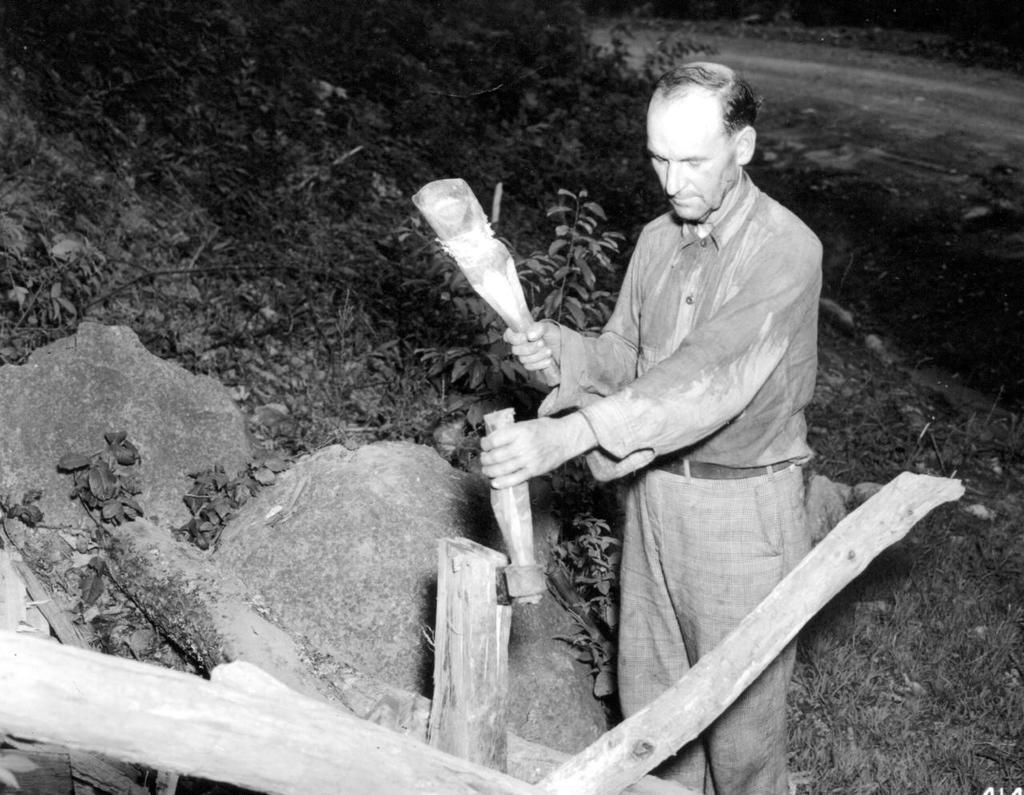What is the color scheme of the image? The image is black and white. Can you describe the person in the image? There is a person standing in the image. What is the person holding in the image? The person is holding objects. What type of natural elements can be seen in the image? There are plants, wood, rocks, and grass on the ground in the image. What is the person saying good-bye to in the image? There is no indication in the image that the person is saying good-bye to anything or anyone. --- Facts: 1. There is a car in the image. 2. The car is red. 3. The car has four wheels. 4. There are people in the car. 5. The car is parked on the street. 6. There are trees in the background of the image. Absurd Topics: parrot, dance, ocean Conversation: What is the main subject of the image? The main subject of the image is a car. What color is the car? The car is red. How many wheels does the car have? The car has four wheels. Who is inside the car? There are people in the car. Where is the car located in the image? The car is parked on the street. What can be seen in the background of the image? There are trees in the background of the image. Reasoning: Let's think step by step in order to produce the conversation. We start by identifying the main subject of the image, which is the car. Then, we describe the car's color and the number of wheels it has. Next, we mention the people inside the car. After that, we describe the car's location, which is parked on the street. Finally, we identify the natural elements present in the background of the image, which are trees. Absurd Question/Answer: Can you see a parrot dancing near the ocean in the image? There is no parrot, dancing, or ocean present in the image. 